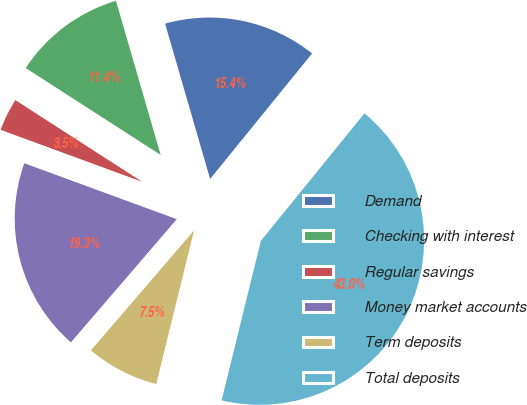<chart> <loc_0><loc_0><loc_500><loc_500><pie_chart><fcel>Demand<fcel>Checking with interest<fcel>Regular savings<fcel>Money market accounts<fcel>Term deposits<fcel>Total deposits<nl><fcel>15.35%<fcel>11.4%<fcel>3.51%<fcel>19.3%<fcel>7.46%<fcel>42.98%<nl></chart> 